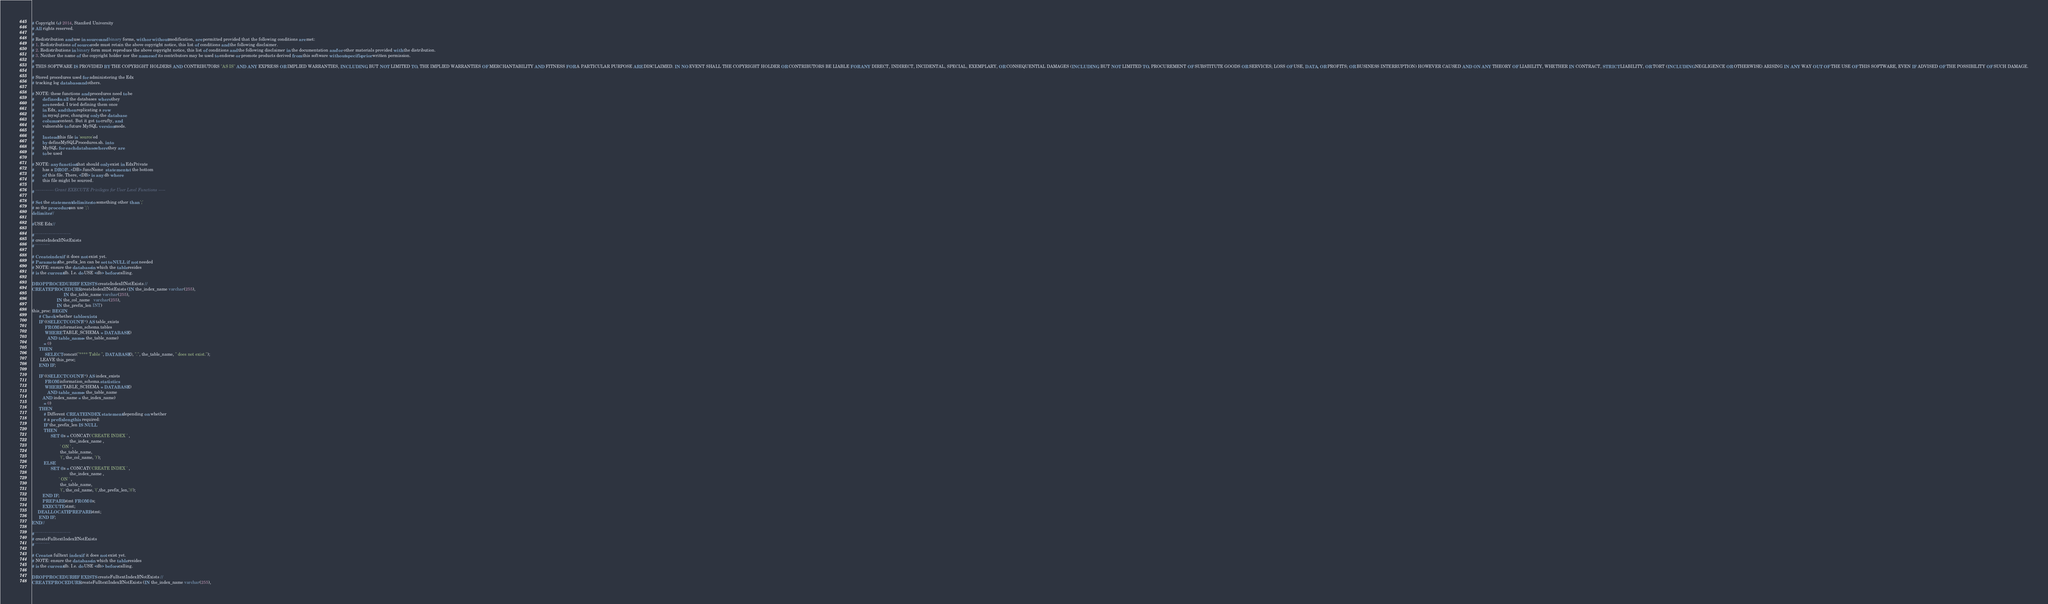<code> <loc_0><loc_0><loc_500><loc_500><_SQL_># Copyright (c) 2014, Stanford University
# All rights reserved.
#
# Redistribution and use in source and binary forms, with or without modification, are permitted provided that the following conditions are met:
# 1. Redistributions of source code must retain the above copyright notice, this list of conditions and the following disclaimer.
# 2. Redistributions in binary form must reproduce the above copyright notice, this list of conditions and the following disclaimer in the documentation and/or other materials provided with the distribution.
# 3. Neither the name of the copyright holder nor the names of its contributors may be used to endorse or promote products derived from this software without specific prior written permission.
#
# THIS SOFTWARE IS PROVIDED BY THE COPYRIGHT HOLDERS AND CONTRIBUTORS "AS IS" AND ANY EXPRESS OR IMPLIED WARRANTIES, INCLUDING, BUT NOT LIMITED TO, THE IMPLIED WARRANTIES OF MERCHANTABILITY AND FITNESS FOR A PARTICULAR PURPOSE ARE DISCLAIMED. IN NO EVENT SHALL THE COPYRIGHT HOLDER OR CONTRIBUTORS BE LIABLE FOR ANY DIRECT, INDIRECT, INCIDENTAL, SPECIAL, EXEMPLARY, OR CONSEQUENTIAL DAMAGES (INCLUDING, BUT NOT LIMITED TO, PROCUREMENT OF SUBSTITUTE GOODS OR SERVICES; LOSS OF USE, DATA, OR PROFITS; OR BUSINESS INTERRUPTION) HOWEVER CAUSED AND ON ANY THEORY OF LIABILITY, WHETHER IN CONTRACT, STRICT LIABILITY, OR TORT (INCLUDING NEGLIGENCE OR OTHERWISE) ARISING IN ANY WAY OUT OF THE USE OF THIS SOFTWARE, EVEN IF ADVISED OF THE POSSIBILITY OF SUCH DAMAGE.

# Stored procedures used for administering the Edx
# tracking log database and others.

# NOTE: these functions and procedures need to be
#       defined in all the databases where they
#       are needed. I tried defining them once
#       in Edx, and then replicating a row
#       in mysql.proc, changing only the database
#       column content. But it got to crufty, and
#       vulnerable to future MySQL version mods.
#
#       Instead this file is 'source'ed
#       by defineMySQLProcedures.sh. into
#       MySQL for each database where they are
#       to be used

# NOTE: any function that should only exist in EdxPrivate
#       has a DROP...<DB>.funcName  statement at the bottom
#       of this file. There, <DB> is any db where
#       this file might be sourced.

# ------------- Grant EXECUTE Privileges for User Level Functions -----

# Set the statement delimiter to something other than ';'
# so the procedure can use ';':
delimiter //

#USE Edx//

#--------------------------
# createIndexIfNotExists
#-----------

# Create index if it does not exist yet.
# Parameter the_prefix_len can be set to NULL if not needed
# NOTE: ensure the database in which the table resides
# is the current db. I.e. do USE <db> before calling.

DROP PROCEDURE IF EXISTS createIndexIfNotExists //
CREATE PROCEDURE createIndexIfNotExists (IN the_index_name varchar(255),
                           IN the_table_name varchar(255),
                     IN the_col_name   varchar(255),
                     IN the_prefix_len INT)
this_proc: BEGIN
      # Check whether table exists:
      IF ((SELECT COUNT(*) AS table_exists
           FROM information_schema.tables
           WHERE TABLE_SCHEMA = DATABASE()
             AND table_name = the_table_name)
          = 0)
      THEN
           SELECT concat("**** Table ", DATABASE(), ".", the_table_name, " does not exist.");
       LEAVE this_proc;
      END IF;

      IF ((SELECT COUNT(*) AS index_exists
           FROM information_schema.statistics
           WHERE TABLE_SCHEMA = DATABASE()
             AND table_name = the_table_name
         AND index_name = the_index_name)
          = 0)
      THEN
          # Different CREATE INDEX statement depending on whether
          # a prefix length is required:
          IF the_prefix_len IS NULL
          THEN
                SET @s = CONCAT('CREATE INDEX ' ,
                                the_index_name ,
                        ' ON ' ,
                        the_table_name,
                        '(', the_col_name, ')');
          ELSE
                SET @s = CONCAT('CREATE INDEX ' ,
                                the_index_name ,
                       ' ON ' ,
                        the_table_name,
                        '(', the_col_name, '(',the_prefix_len,'))');
         END IF;
         PREPARE stmt FROM @s;
         EXECUTE stmt;
	 DEALLOCATE PREPARE stmt;
      END IF;
END//

#--------------------------
# createFulltextIndexIfNotExists
#-----------

# Create a fulltext index if it does not exist yet.
# NOTE: ensure the database in which the table resides
# is the current db. I.e. do USE <db> before calling.

DROP PROCEDURE IF EXISTS createFulltextIndexIfNotExists //
CREATE PROCEDURE createFulltextIndexIfNotExists (IN the_index_name varchar(255),</code> 